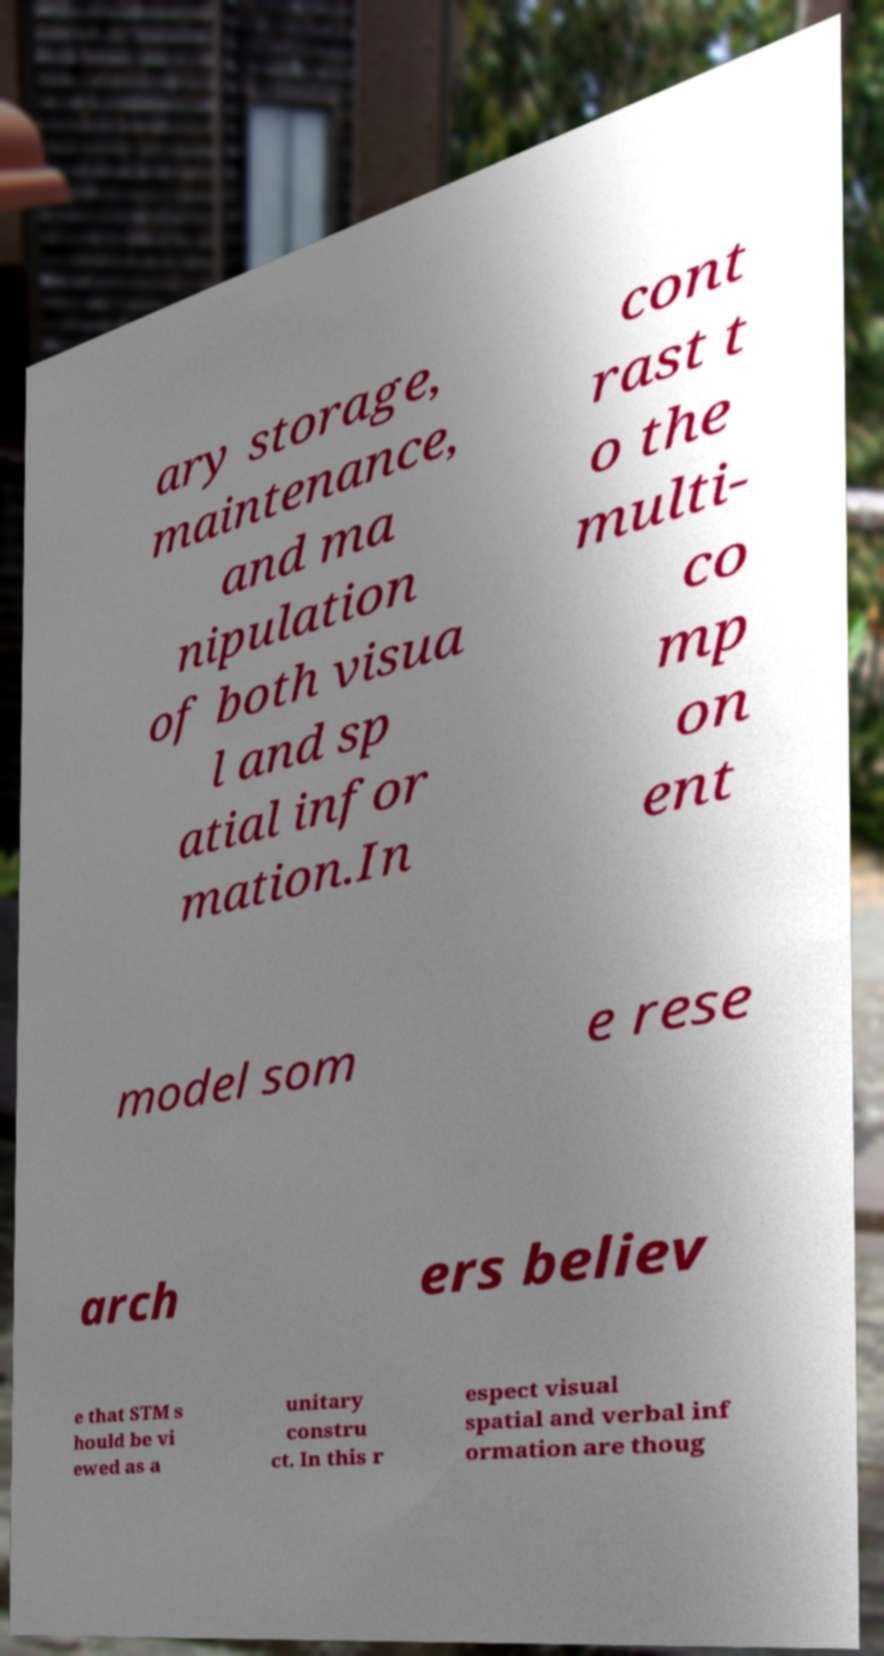Could you extract and type out the text from this image? ary storage, maintenance, and ma nipulation of both visua l and sp atial infor mation.In cont rast t o the multi- co mp on ent model som e rese arch ers believ e that STM s hould be vi ewed as a unitary constru ct. In this r espect visual spatial and verbal inf ormation are thoug 